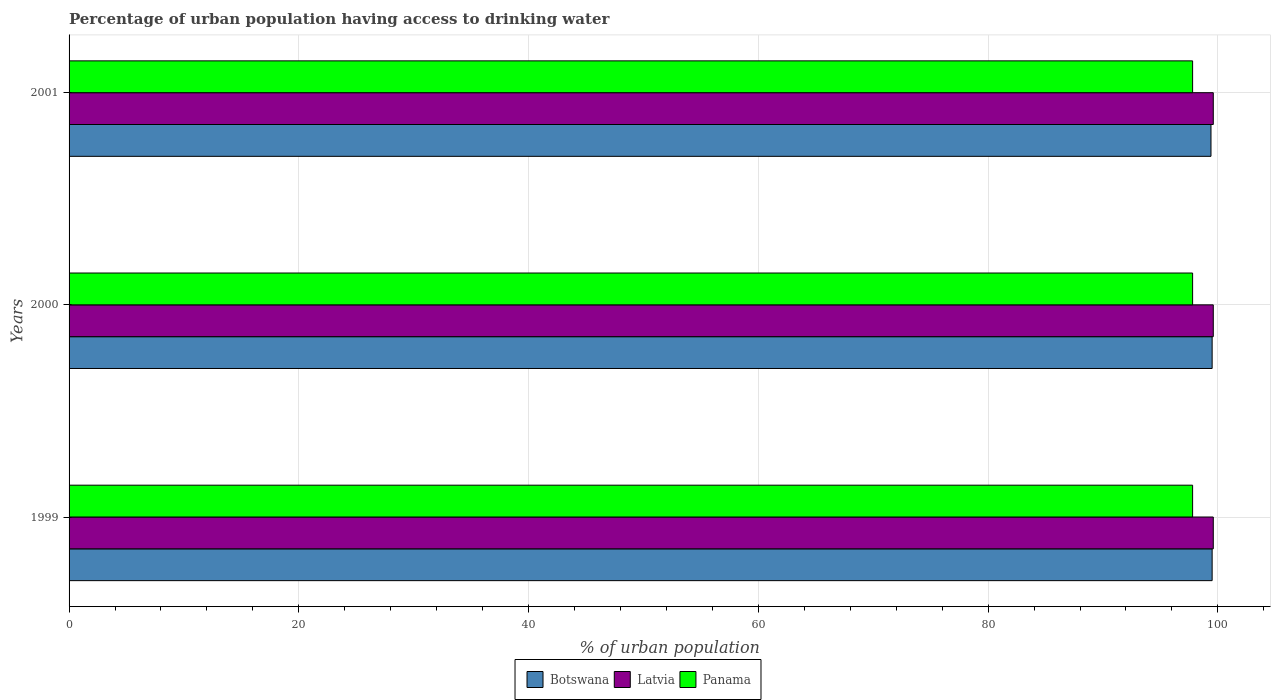How many different coloured bars are there?
Offer a terse response. 3. How many groups of bars are there?
Provide a short and direct response. 3. Are the number of bars per tick equal to the number of legend labels?
Make the answer very short. Yes. How many bars are there on the 2nd tick from the bottom?
Keep it short and to the point. 3. In how many cases, is the number of bars for a given year not equal to the number of legend labels?
Give a very brief answer. 0. What is the percentage of urban population having access to drinking water in Latvia in 2001?
Give a very brief answer. 99.6. Across all years, what is the maximum percentage of urban population having access to drinking water in Panama?
Keep it short and to the point. 97.8. Across all years, what is the minimum percentage of urban population having access to drinking water in Botswana?
Make the answer very short. 99.4. In which year was the percentage of urban population having access to drinking water in Panama minimum?
Your answer should be very brief. 1999. What is the total percentage of urban population having access to drinking water in Latvia in the graph?
Provide a short and direct response. 298.8. What is the difference between the percentage of urban population having access to drinking water in Botswana in 2000 and that in 2001?
Provide a short and direct response. 0.1. What is the difference between the percentage of urban population having access to drinking water in Panama in 2000 and the percentage of urban population having access to drinking water in Botswana in 2001?
Provide a succinct answer. -1.6. What is the average percentage of urban population having access to drinking water in Latvia per year?
Ensure brevity in your answer.  99.6. In the year 1999, what is the difference between the percentage of urban population having access to drinking water in Panama and percentage of urban population having access to drinking water in Botswana?
Your response must be concise. -1.7. In how many years, is the percentage of urban population having access to drinking water in Botswana greater than 16 %?
Keep it short and to the point. 3. In how many years, is the percentage of urban population having access to drinking water in Latvia greater than the average percentage of urban population having access to drinking water in Latvia taken over all years?
Keep it short and to the point. 3. Is the sum of the percentage of urban population having access to drinking water in Panama in 2000 and 2001 greater than the maximum percentage of urban population having access to drinking water in Botswana across all years?
Offer a terse response. Yes. What does the 3rd bar from the top in 1999 represents?
Your response must be concise. Botswana. What does the 2nd bar from the bottom in 2001 represents?
Make the answer very short. Latvia. Are all the bars in the graph horizontal?
Your response must be concise. Yes. Does the graph contain grids?
Make the answer very short. Yes. What is the title of the graph?
Provide a succinct answer. Percentage of urban population having access to drinking water. What is the label or title of the X-axis?
Ensure brevity in your answer.  % of urban population. What is the label or title of the Y-axis?
Provide a succinct answer. Years. What is the % of urban population of Botswana in 1999?
Provide a succinct answer. 99.5. What is the % of urban population of Latvia in 1999?
Your response must be concise. 99.6. What is the % of urban population in Panama in 1999?
Make the answer very short. 97.8. What is the % of urban population in Botswana in 2000?
Give a very brief answer. 99.5. What is the % of urban population of Latvia in 2000?
Provide a succinct answer. 99.6. What is the % of urban population in Panama in 2000?
Your answer should be very brief. 97.8. What is the % of urban population of Botswana in 2001?
Make the answer very short. 99.4. What is the % of urban population of Latvia in 2001?
Keep it short and to the point. 99.6. What is the % of urban population in Panama in 2001?
Make the answer very short. 97.8. Across all years, what is the maximum % of urban population of Botswana?
Make the answer very short. 99.5. Across all years, what is the maximum % of urban population in Latvia?
Ensure brevity in your answer.  99.6. Across all years, what is the maximum % of urban population in Panama?
Provide a short and direct response. 97.8. Across all years, what is the minimum % of urban population of Botswana?
Your answer should be compact. 99.4. Across all years, what is the minimum % of urban population of Latvia?
Your answer should be very brief. 99.6. Across all years, what is the minimum % of urban population in Panama?
Give a very brief answer. 97.8. What is the total % of urban population of Botswana in the graph?
Give a very brief answer. 298.4. What is the total % of urban population in Latvia in the graph?
Ensure brevity in your answer.  298.8. What is the total % of urban population of Panama in the graph?
Your answer should be very brief. 293.4. What is the difference between the % of urban population in Botswana in 1999 and that in 2000?
Offer a very short reply. 0. What is the difference between the % of urban population in Latvia in 1999 and that in 2000?
Your response must be concise. 0. What is the difference between the % of urban population of Panama in 1999 and that in 2001?
Your answer should be very brief. 0. What is the difference between the % of urban population in Latvia in 2000 and that in 2001?
Your response must be concise. 0. What is the difference between the % of urban population of Panama in 2000 and that in 2001?
Give a very brief answer. 0. What is the difference between the % of urban population in Botswana in 1999 and the % of urban population in Latvia in 2000?
Provide a succinct answer. -0.1. What is the difference between the % of urban population of Botswana in 1999 and the % of urban population of Panama in 2000?
Your answer should be compact. 1.7. What is the difference between the % of urban population in Latvia in 1999 and the % of urban population in Panama in 2000?
Offer a terse response. 1.8. What is the difference between the % of urban population in Botswana in 1999 and the % of urban population in Latvia in 2001?
Give a very brief answer. -0.1. What is the difference between the % of urban population of Latvia in 2000 and the % of urban population of Panama in 2001?
Your answer should be very brief. 1.8. What is the average % of urban population in Botswana per year?
Keep it short and to the point. 99.47. What is the average % of urban population of Latvia per year?
Ensure brevity in your answer.  99.6. What is the average % of urban population in Panama per year?
Keep it short and to the point. 97.8. In the year 1999, what is the difference between the % of urban population in Botswana and % of urban population in Panama?
Give a very brief answer. 1.7. In the year 2000, what is the difference between the % of urban population of Botswana and % of urban population of Latvia?
Make the answer very short. -0.1. In the year 2001, what is the difference between the % of urban population in Botswana and % of urban population in Latvia?
Keep it short and to the point. -0.2. What is the ratio of the % of urban population in Botswana in 1999 to that in 2001?
Provide a short and direct response. 1. What is the ratio of the % of urban population in Latvia in 1999 to that in 2001?
Give a very brief answer. 1. What is the ratio of the % of urban population in Panama in 1999 to that in 2001?
Provide a succinct answer. 1. What is the ratio of the % of urban population of Botswana in 2000 to that in 2001?
Give a very brief answer. 1. What is the ratio of the % of urban population of Panama in 2000 to that in 2001?
Make the answer very short. 1. What is the difference between the highest and the second highest % of urban population of Botswana?
Offer a terse response. 0. What is the difference between the highest and the second highest % of urban population of Panama?
Offer a very short reply. 0. What is the difference between the highest and the lowest % of urban population of Botswana?
Keep it short and to the point. 0.1. 